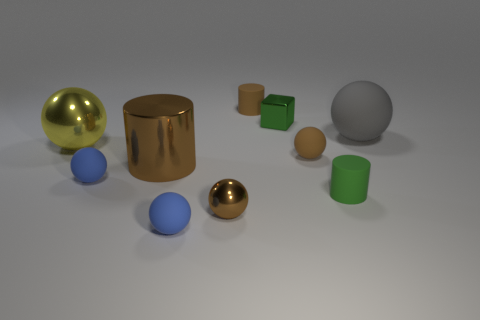Subtract all yellow balls. How many balls are left? 5 Subtract 3 spheres. How many spheres are left? 3 Subtract all gray balls. How many balls are left? 5 Subtract all gray balls. Subtract all blue cubes. How many balls are left? 5 Subtract all cylinders. How many objects are left? 7 Subtract 0 red cylinders. How many objects are left? 10 Subtract all gray things. Subtract all tiny green rubber cylinders. How many objects are left? 8 Add 8 metallic spheres. How many metallic spheres are left? 10 Add 9 cyan cylinders. How many cyan cylinders exist? 9 